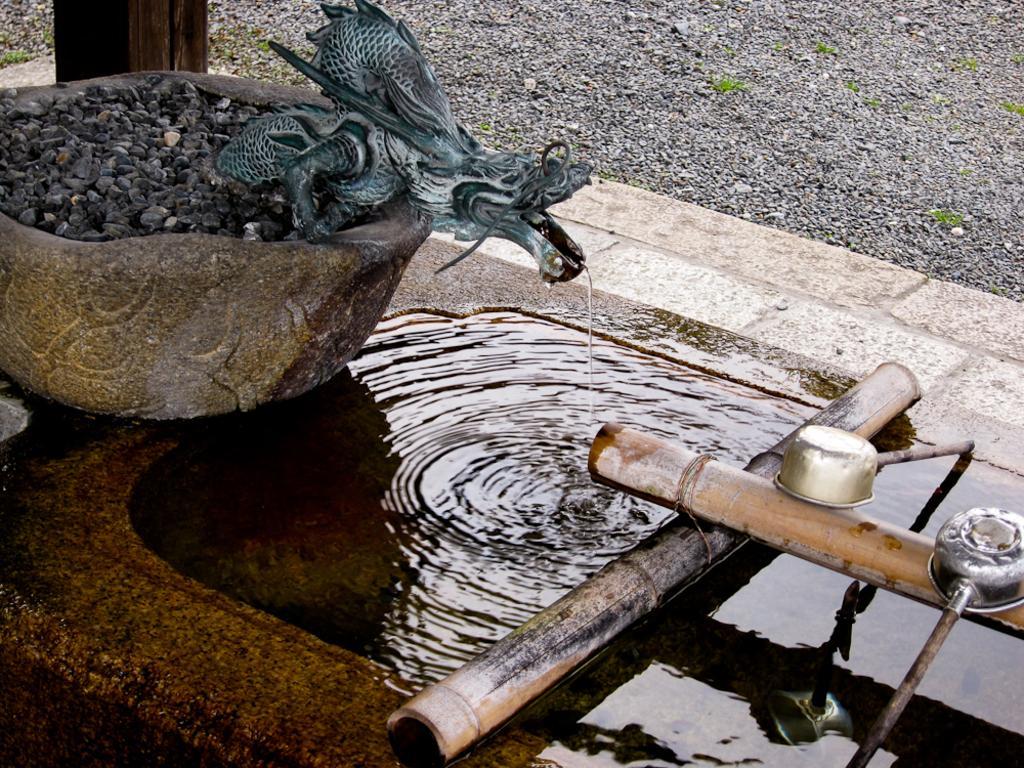In one or two sentences, can you explain what this image depicts? In this picture there is an object in the left corner and there is a dragon statue on it where the flow of water comes from the mouth of the dragon statue and there are few other objects in the right corner. 